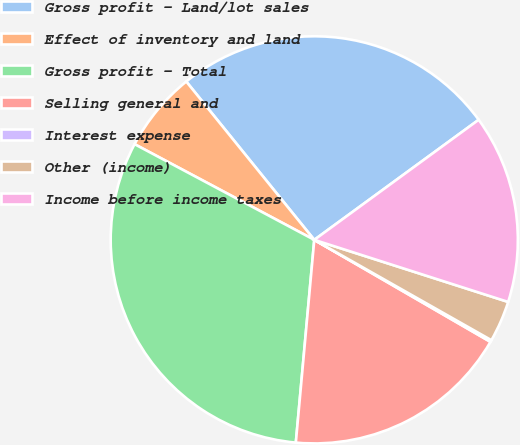<chart> <loc_0><loc_0><loc_500><loc_500><pie_chart><fcel>Gross profit - Land/lot sales<fcel>Effect of inventory and land<fcel>Gross profit - Total<fcel>Selling general and<fcel>Interest expense<fcel>Other (income)<fcel>Income before income taxes<nl><fcel>25.78%<fcel>6.39%<fcel>31.34%<fcel>18.09%<fcel>0.15%<fcel>3.27%<fcel>14.97%<nl></chart> 